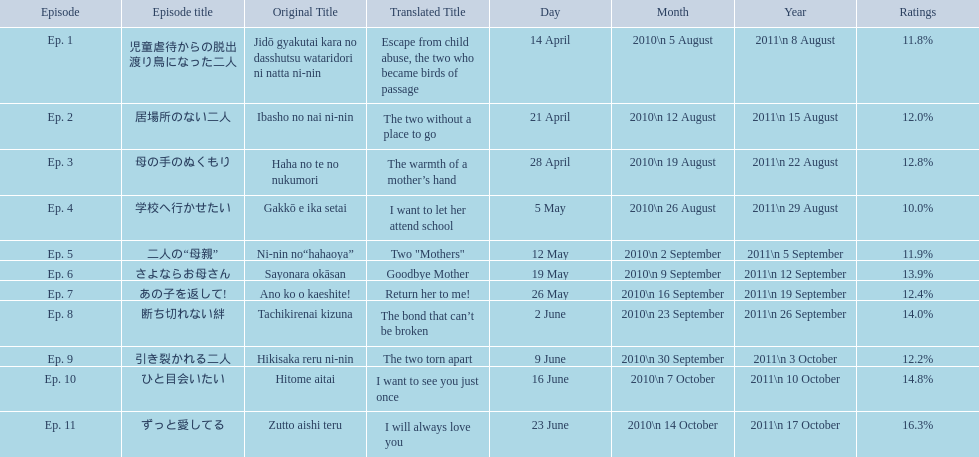What are all the titles the episodes of the mother tv series? 児童虐待からの脱出 渡り鳥になった二人, 居場所のない二人, 母の手のぬくもり, 学校へ行かせたい, 二人の“母親”, さよならお母さん, あの子を返して!, 断ち切れない絆, 引き裂かれる二人, ひと目会いたい, ずっと愛してる. What are all of the ratings for each of the shows? 11.8%, 12.0%, 12.8%, 10.0%, 11.9%, 13.9%, 12.4%, 14.0%, 12.2%, 14.8%, 16.3%. What is the highest score for ratings? 16.3%. What episode corresponds to that rating? ずっと愛してる. 